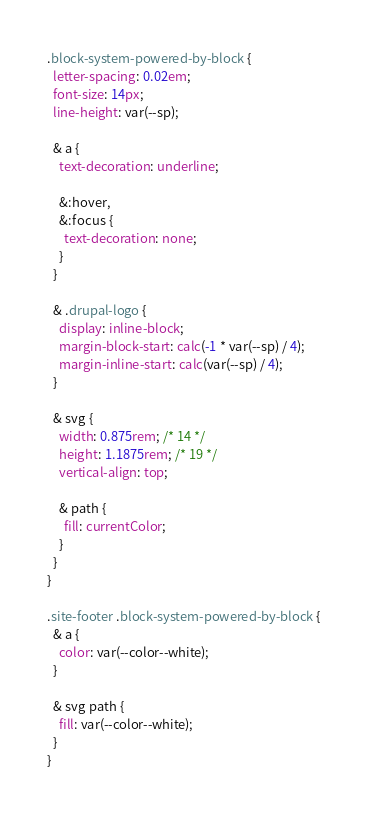<code> <loc_0><loc_0><loc_500><loc_500><_CSS_>
.block-system-powered-by-block {
  letter-spacing: 0.02em;
  font-size: 14px;
  line-height: var(--sp);

  & a {
    text-decoration: underline;

    &:hover,
    &:focus {
      text-decoration: none;
    }
  }

  & .drupal-logo {
    display: inline-block;
    margin-block-start: calc(-1 * var(--sp) / 4);
    margin-inline-start: calc(var(--sp) / 4);
  }

  & svg {
    width: 0.875rem; /* 14 */
    height: 1.1875rem; /* 19 */
    vertical-align: top;

    & path {
      fill: currentColor;
    }
  }
}

.site-footer .block-system-powered-by-block {
  & a {
    color: var(--color--white);
  }

  & svg path {
    fill: var(--color--white);
  }
}
</code> 